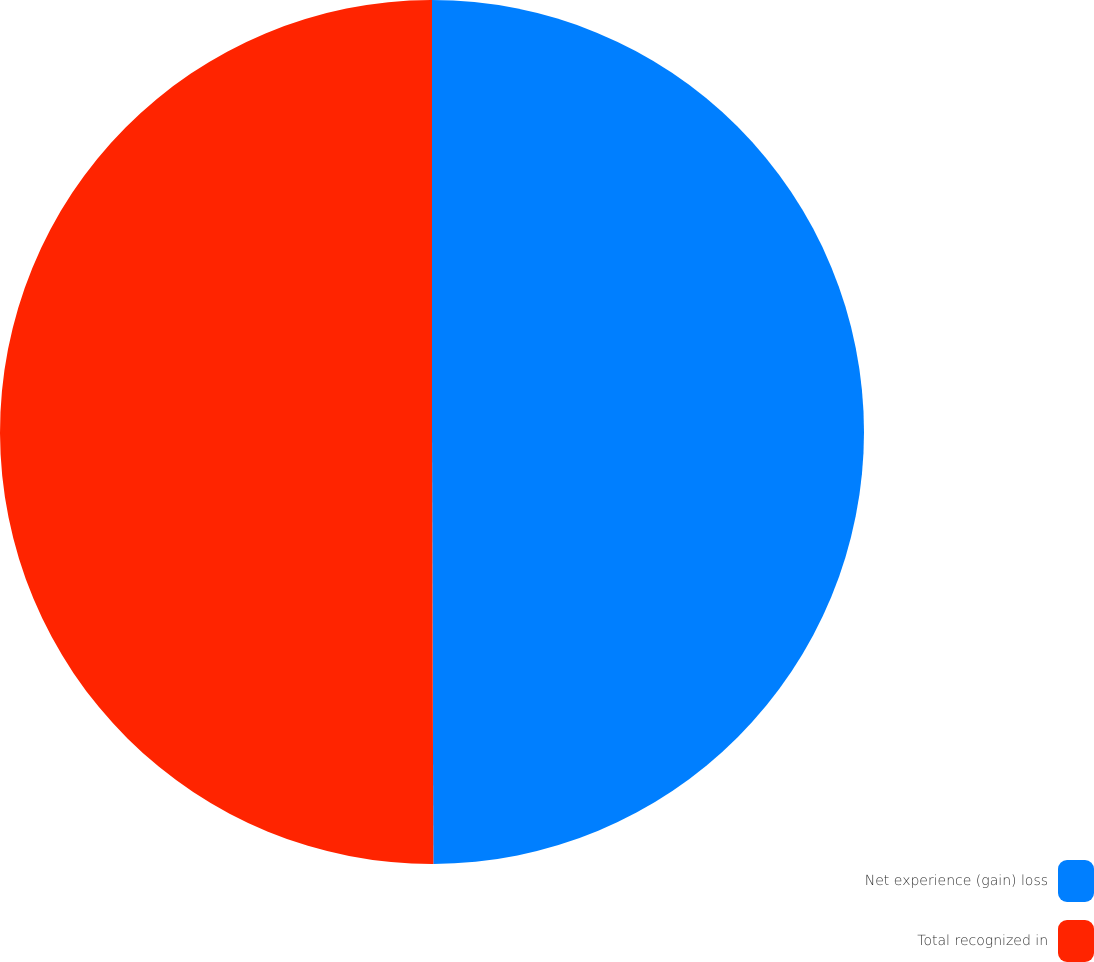Convert chart to OTSL. <chart><loc_0><loc_0><loc_500><loc_500><pie_chart><fcel>Net experience (gain) loss<fcel>Total recognized in<nl><fcel>49.95%<fcel>50.05%<nl></chart> 